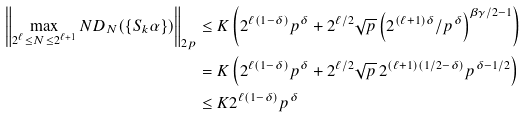Convert formula to latex. <formula><loc_0><loc_0><loc_500><loc_500>\left \| \max _ { 2 ^ { \ell } \leq N \leq 2 ^ { \ell + 1 } } N D _ { N } ( \{ S _ { k } \alpha \} ) \right \| _ { 2 p } & \leq K \left ( 2 ^ { \ell ( 1 - \delta ) } p ^ { \delta } + 2 ^ { \ell / 2 } \sqrt { p } \left ( 2 ^ { ( \ell + 1 ) \delta } / p ^ { \delta } \right ) ^ { \beta \gamma / 2 - 1 } \right ) \\ & = K \left ( 2 ^ { \ell ( 1 - \delta ) } p ^ { \delta } + 2 ^ { \ell / 2 } \sqrt { p } \, 2 ^ { ( \ell + 1 ) ( 1 / 2 - \delta ) } p ^ { \delta - 1 / 2 } \right ) \\ & \leq K 2 ^ { \ell ( 1 - \delta ) } p ^ { \delta }</formula> 